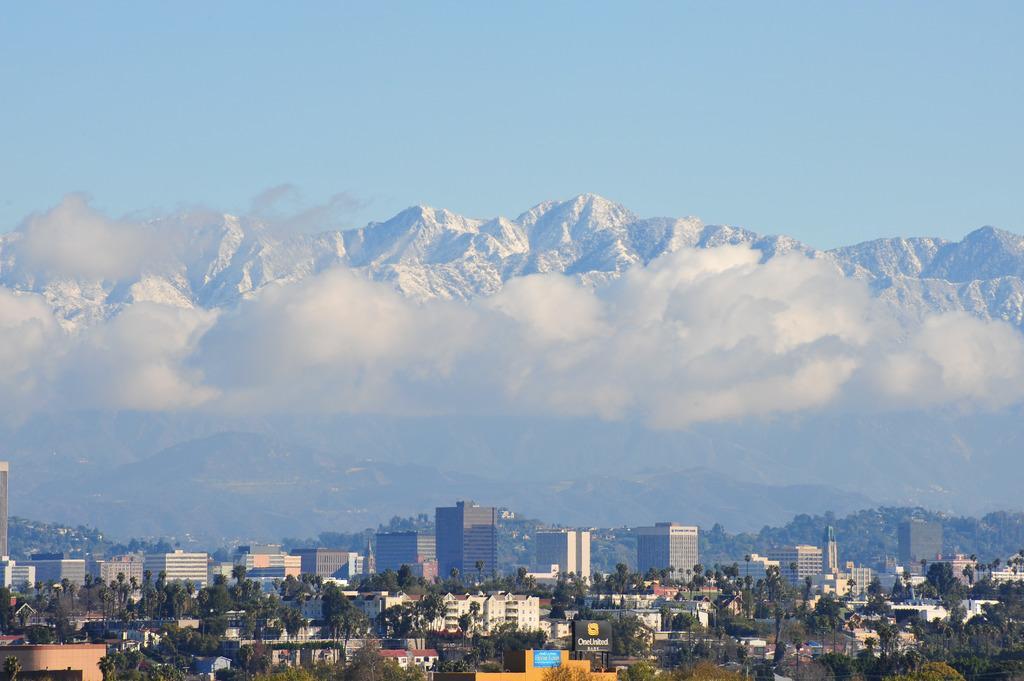Could you give a brief overview of what you see in this image? In this image I can see so many buildings and trees at the back there is a snow mountain and clouds. 